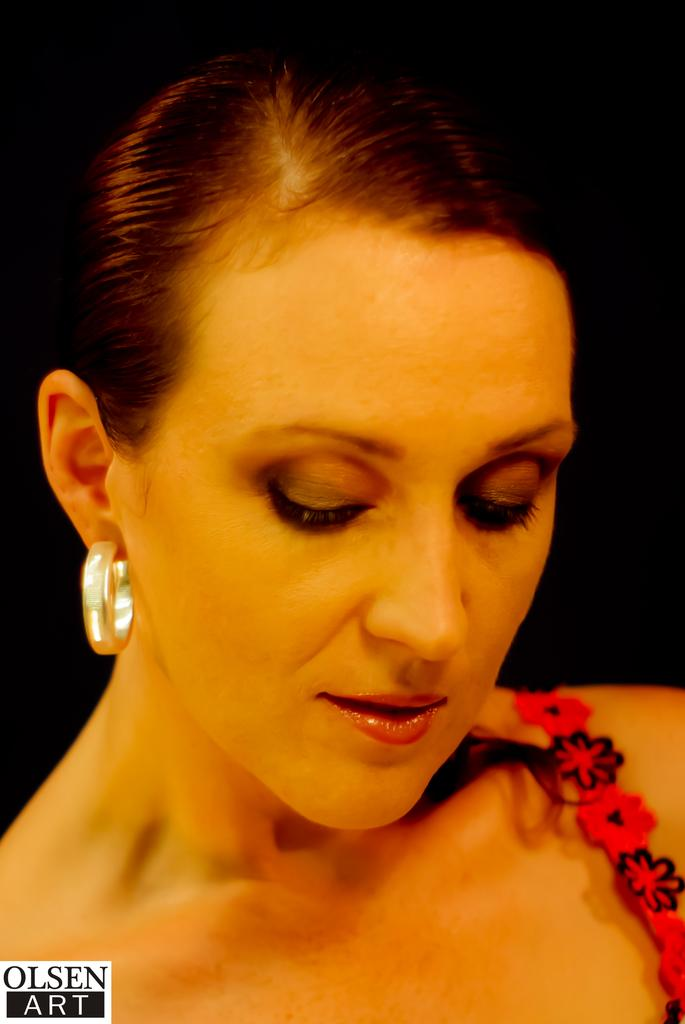Who is the main subject in the image? There is a woman in the image. What is the woman wearing in the image? The woman is wearing a red dress and an earring. What is the woman doing in the image? The woman is looking downwards. Can you see any farm animals in the image? There are no farm animals present in the image. Is the woman depicted as a slave in the image? There is no indication in the image that the woman is depicted as a slave. 